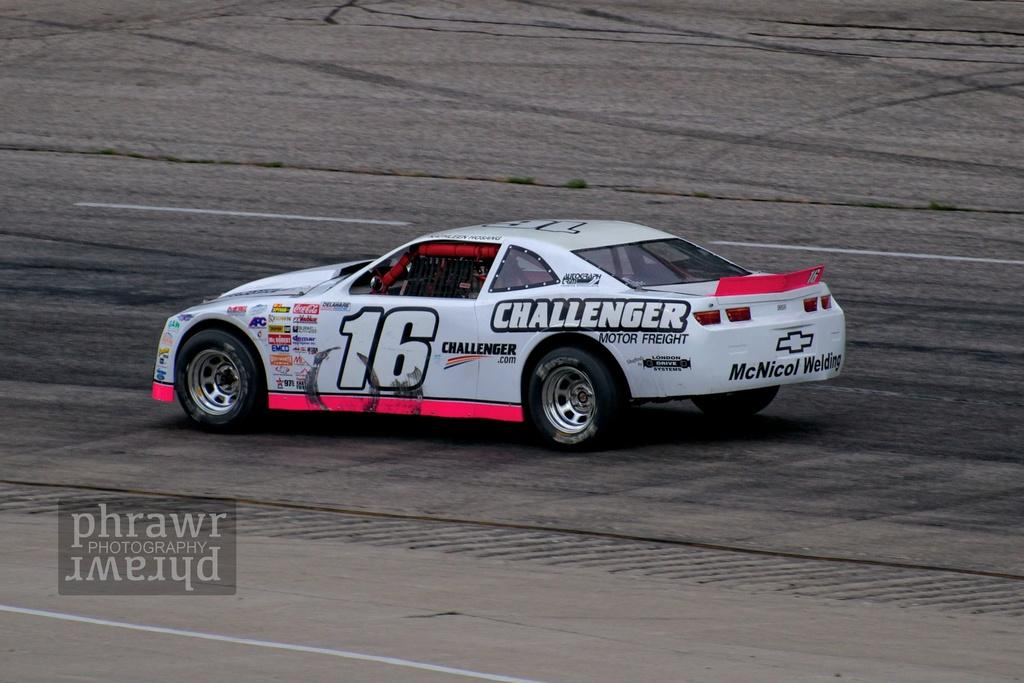What is the main subject of the image? The main subject of the image is a car. Where is the car located in the image? The car is on the road in the image. Can you see the car's toes in the image? There are no toes present in the image, as it features a car on the road. 